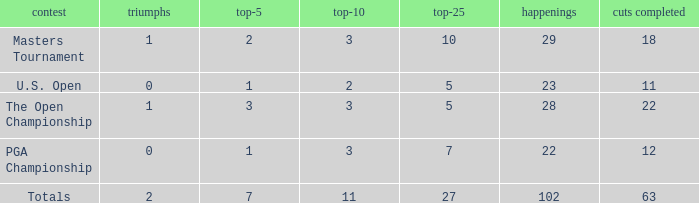How many top 10s when he had under 1 top 5s? None. 